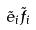Convert formula to latex. <formula><loc_0><loc_0><loc_500><loc_500>\tilde { e } _ { i } \tilde { f } _ { i }</formula> 